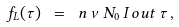Convert formula to latex. <formula><loc_0><loc_0><loc_500><loc_500>f _ { L } ( \tau ) \ = \ n \, \nu \, N _ { 0 } \, I _ { \, } o u t \, \tau \, ,</formula> 